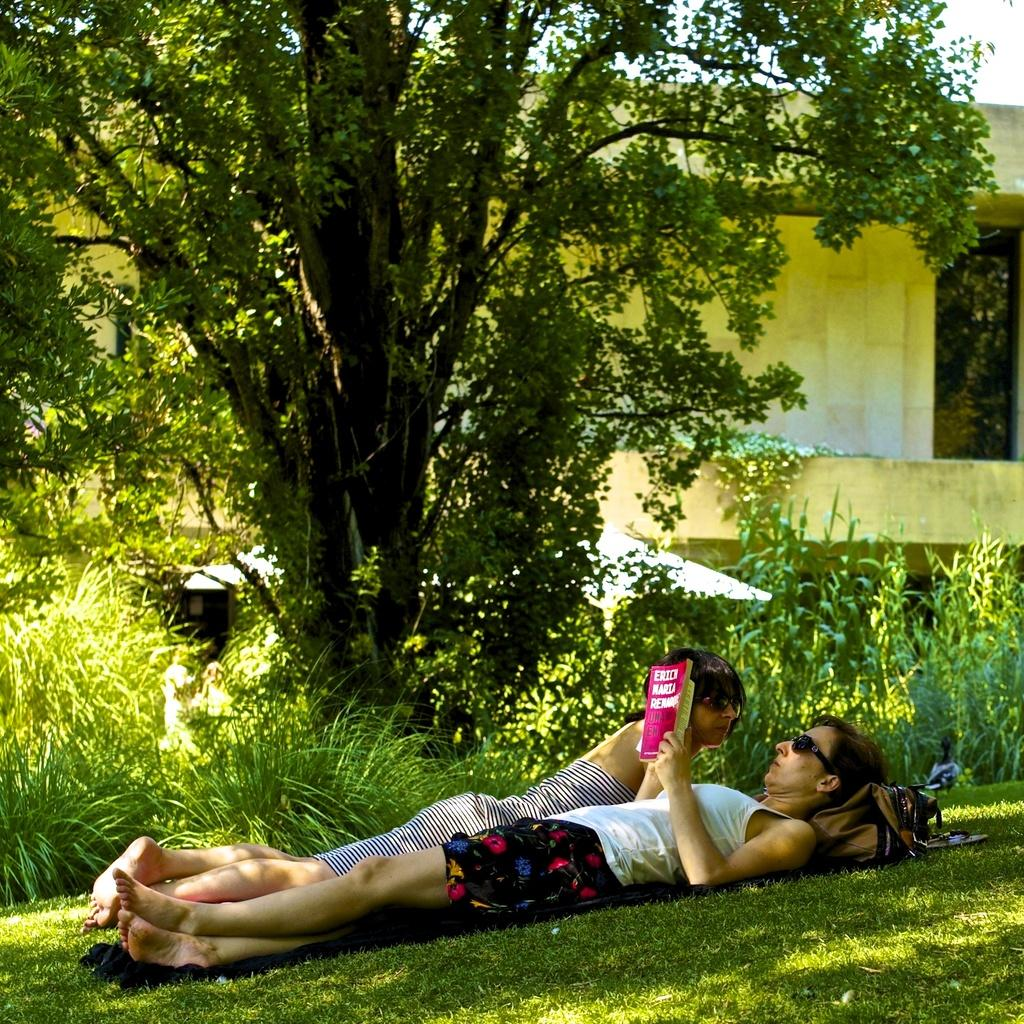What are the two people in the image doing? The two people are lying on the grass in the image. What objects can be seen near the people? There is a bag and a book in the image. What type of surface is visible at the bottom of the image? There is grass visible at the bottom of the image. What can be seen in the background of the image? There is a tree, a building, and the sky visible in the background of the image. What type of polish is being applied to the turkey in the image? There is no turkey or polish present in the image. Where is the lunchroom located in the image? There is no mention of a lunchroom in the image. 